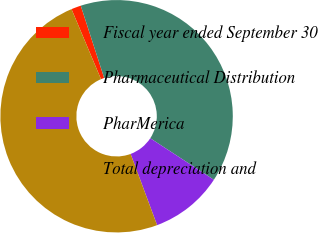Convert chart to OTSL. <chart><loc_0><loc_0><loc_500><loc_500><pie_chart><fcel>Fiscal year ended September 30<fcel>Pharmaceutical Distribution<fcel>PharMerica<fcel>Total depreciation and<nl><fcel>1.35%<fcel>39.2%<fcel>10.12%<fcel>49.33%<nl></chart> 